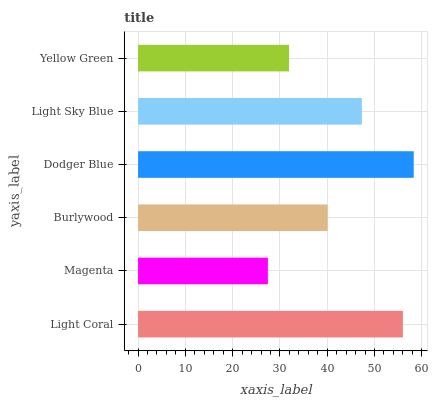Is Magenta the minimum?
Answer yes or no. Yes. Is Dodger Blue the maximum?
Answer yes or no. Yes. Is Burlywood the minimum?
Answer yes or no. No. Is Burlywood the maximum?
Answer yes or no. No. Is Burlywood greater than Magenta?
Answer yes or no. Yes. Is Magenta less than Burlywood?
Answer yes or no. Yes. Is Magenta greater than Burlywood?
Answer yes or no. No. Is Burlywood less than Magenta?
Answer yes or no. No. Is Light Sky Blue the high median?
Answer yes or no. Yes. Is Burlywood the low median?
Answer yes or no. Yes. Is Magenta the high median?
Answer yes or no. No. Is Light Sky Blue the low median?
Answer yes or no. No. 